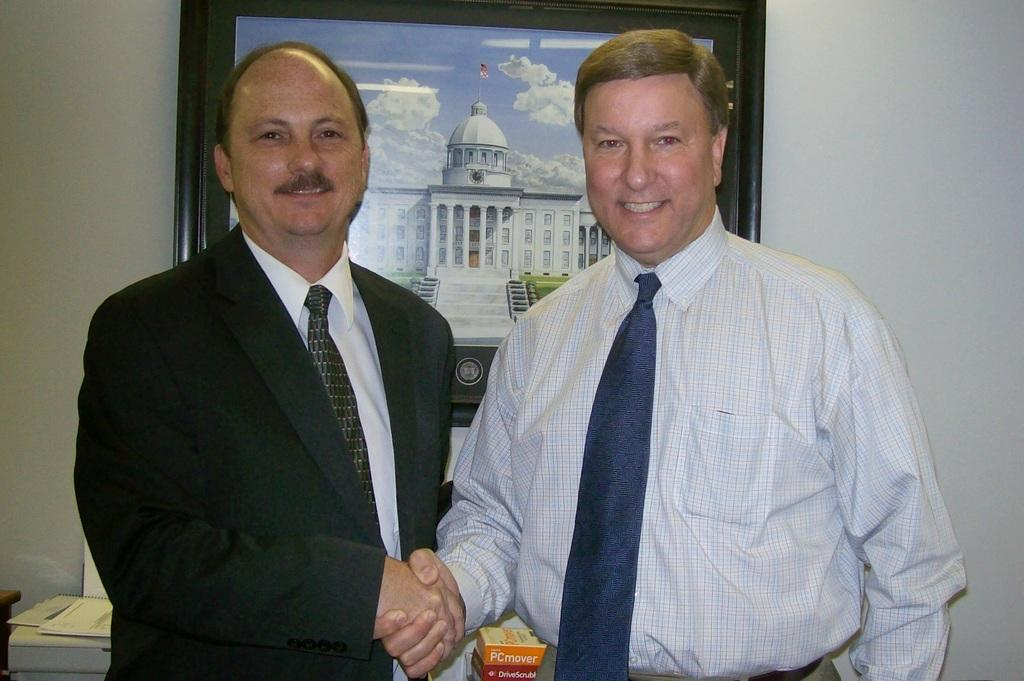How many people are in the image? There are two men in the image. What are the men doing in the image? The men are standing and shaking hands. What is the facial expression of the men in the image? The men are smiling in the image. What objects can be seen in the image besides the men? There are books visible in the image, as well as a wall with a frame. What type of knife is being used by the tiger in the image? There is no tiger or knife present in the image. 